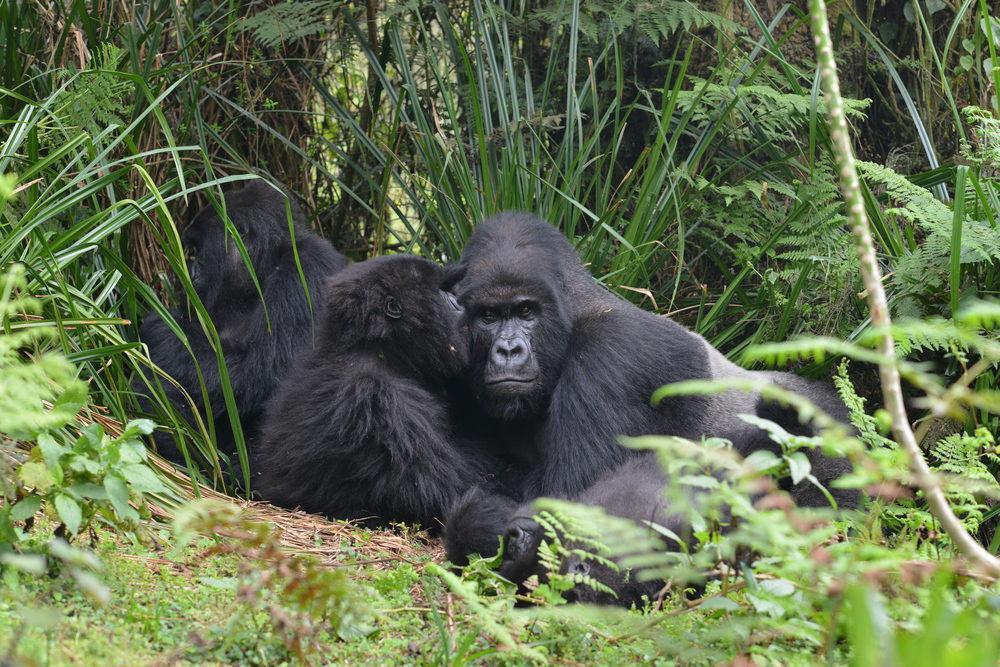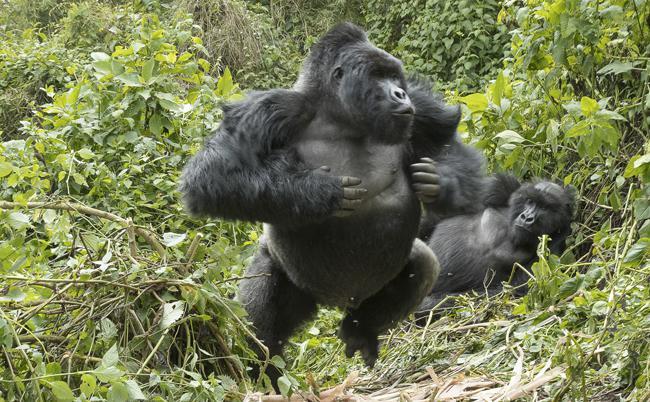The first image is the image on the left, the second image is the image on the right. Evaluate the accuracy of this statement regarding the images: "There are no more than seven gorillas.". Is it true? Answer yes or no. Yes. 